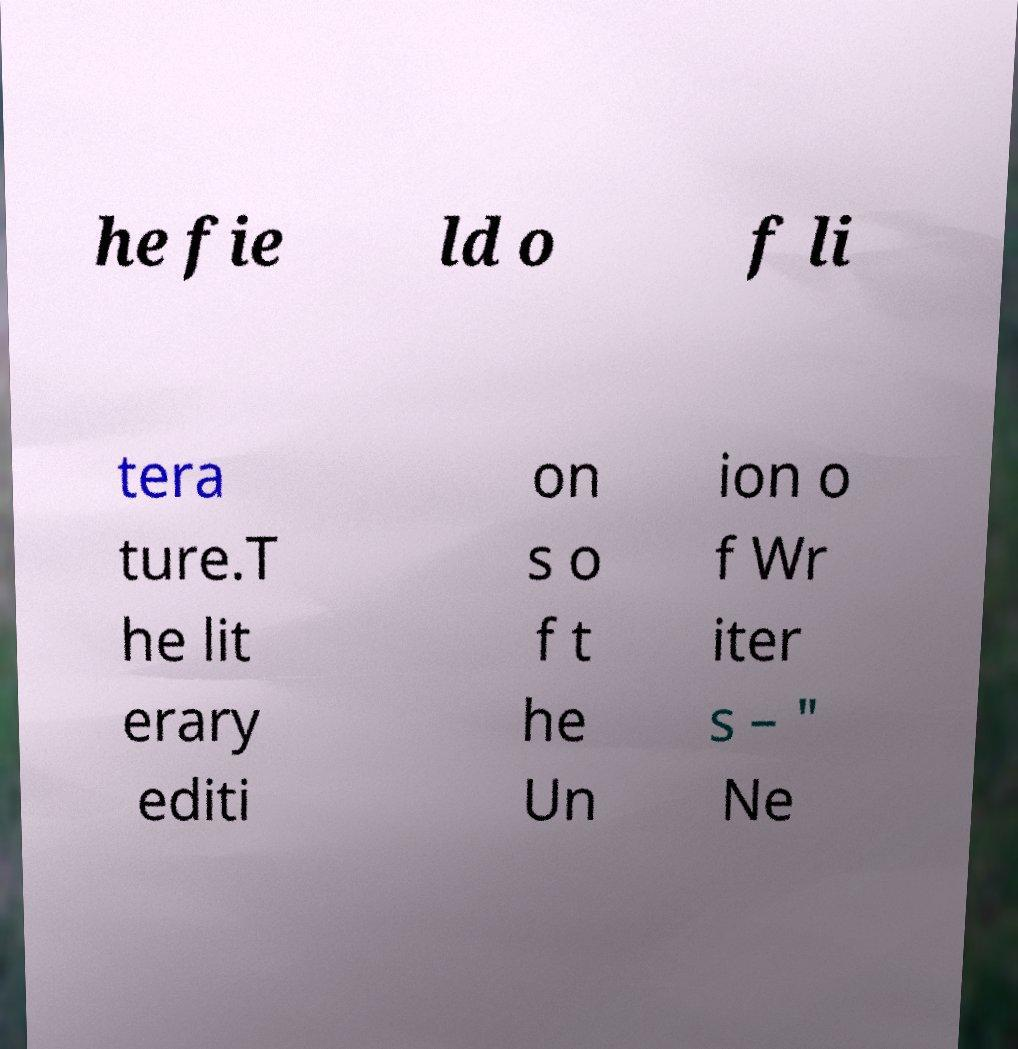For documentation purposes, I need the text within this image transcribed. Could you provide that? he fie ld o f li tera ture.T he lit erary editi on s o f t he Un ion o f Wr iter s – " Ne 